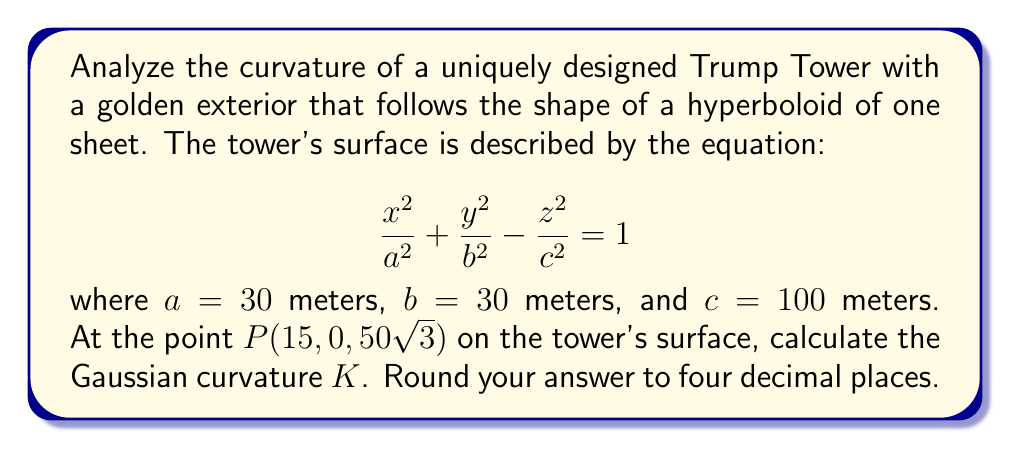Provide a solution to this math problem. To analyze the curvature of the Trump Tower's hyperboloid surface, we'll follow these steps:

1) The Gaussian curvature $K$ of a surface $F(x,y,z) = 0$ at a point $(x,y,z)$ is given by:

   $$K = \frac{H}{EG-F^2}$$

   where $H$ is the Hessian determinant and $E$, $F$, and $G$ are coefficients of the first fundamental form.

2) For our hyperboloid, $F(x,y,z) = \frac{x^2}{a^2} + \frac{y^2}{b^2} - \frac{z^2}{c^2} - 1 = 0$

3) Calculate partial derivatives:
   $$F_x = \frac{2x}{a^2}, F_y = \frac{2y}{b^2}, F_z = -\frac{2z}{c^2}$$
   $$F_{xx} = \frac{2}{a^2}, F_{yy} = \frac{2}{b^2}, F_{zz} = -\frac{2}{c^2}$$
   $$F_{xy} = F_{yz} = F_{xz} = 0$$

4) Calculate the Hessian determinant $H$:
   $$H = \begin{vmatrix}
   F_{xx} & F_{xy} & F_{xz} \\
   F_{yx} & F_{yy} & F_{yz} \\
   F_{zx} & F_{zy} & F_{zz}
   \end{vmatrix} = \frac{2}{a^2} \cdot \frac{2}{b^2} \cdot (-\frac{2}{c^2}) = -\frac{8}{a^2b^2c^2}$$

5) Calculate $E$, $F$, and $G$:
   $$E = F_x^2 + F_y^2 + F_z^2 = \frac{4x^2}{a^4} + \frac{4y^2}{b^4} + \frac{4z^2}{c^4}$$
   $$F = F_xF_y + F_yF_z + F_zF_x = 0$$
   $$G = 1$$

6) At point $P(15, 0, 50\sqrt{3})$, substitute the values:
   $$E = \frac{4(15)^2}{30^4} + \frac{4(0)^2}{30^4} + \frac{4(50\sqrt{3})^2}{100^4} = \frac{1}{100} + \frac{3}{100} = \frac{1}{25}$$

7) Calculate the Gaussian curvature:
   $$K = \frac{H}{EG-F^2} = \frac{-\frac{8}{a^2b^2c^2}}{\frac{1}{25} \cdot 1 - 0^2} = -\frac{8 \cdot 25}{30^2 \cdot 30^2 \cdot 100^2} = -\frac{200}{81,000,000} = -0.0000024691$$

8) Rounding to four decimal places: $K = -0.0000$
Answer: $K = -0.0000$ 